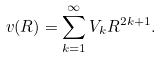Convert formula to latex. <formula><loc_0><loc_0><loc_500><loc_500>v ( R ) = \sum _ { k = 1 } ^ { \infty } V _ { k } R ^ { 2 k + 1 } .</formula> 